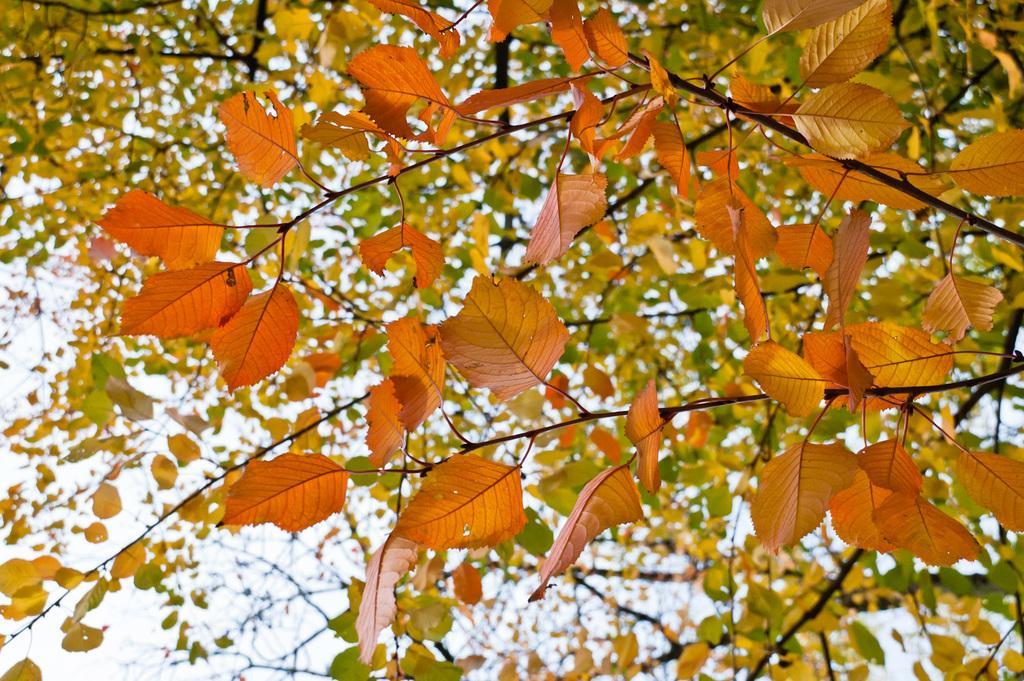In one or two sentences, can you explain what this image depicts? In this image I can see leaves. They are in orange,green and yellow color. The sky is in white color. 